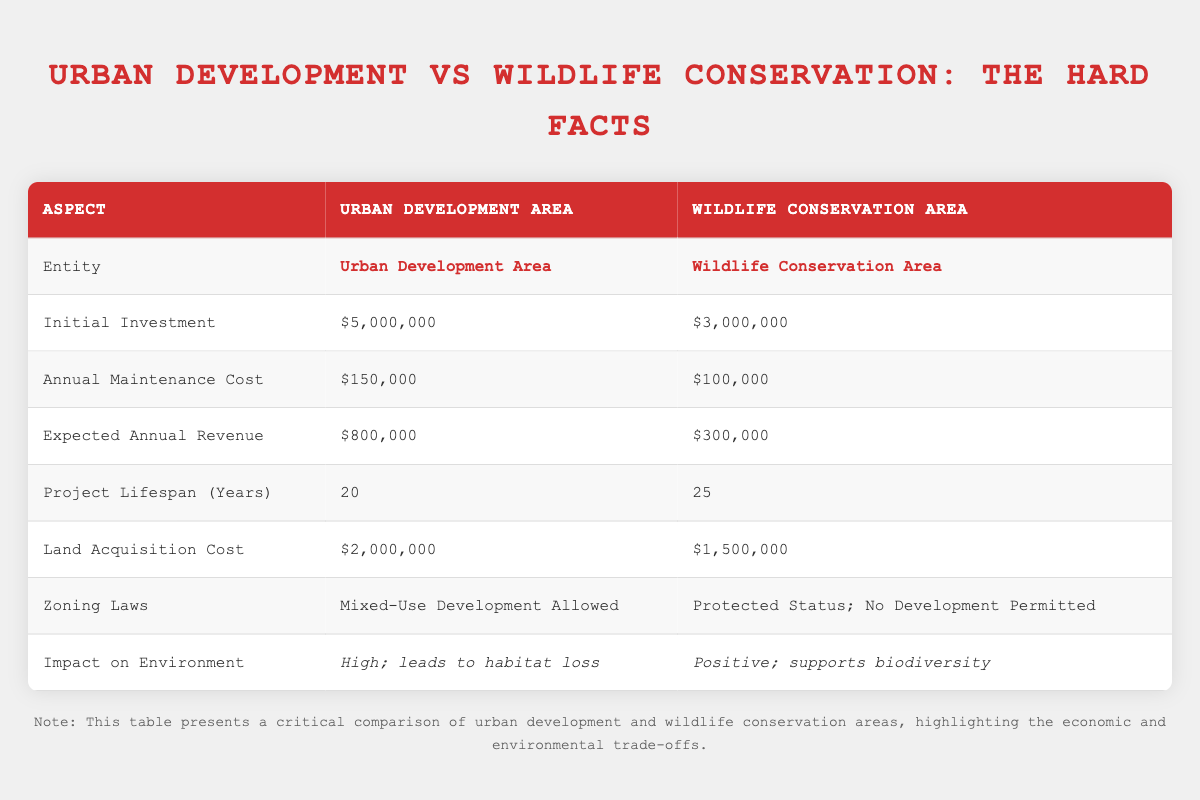What is the initial investment required for the Urban Development Area? The table lists the value under "Initial Investment" for the Urban Development Area, which is $5,000,000.
Answer: $5,000,000 What is the expected annual revenue for the Wildlife Conservation Area? From the table, the expected annual revenue for the Wildlife Conservation Area is directly noted as $300,000.
Answer: $300,000 Which area has a higher annual maintenance cost? Comparing the "Annual Maintenance Cost" for both areas: Urban Development Area has $150,000, while Wildlife Conservation Area has $100,000. Therefore, the Urban Development Area has a higher cost.
Answer: Urban Development Area If we sum the initial investment and land acquisition cost for the Urban Development Area, what total do we get? The initial investment is $5,000,000 and the land acquisition cost is $2,000,000. Adding these amounts gives: $5,000,000 + $2,000,000 = $7,000,000.
Answer: $7,000,000 Is the zoning law for the Wildlife Conservation Area more restrictive than that for the Urban Development Area? The Wildlife Conservation Area has a zoning law of "Protected Status; No Development Permitted," while the Urban Development Area allows "Mixed-Use Development." Thus, the Wildlife Conservation Area has more restrictive zoning laws.
Answer: Yes What is the difference in project lifespan between the urban and wildlife areas? The project lifespan for the Urban Development Area is 20 years, while for the Wildlife Conservation Area it is 25 years. The difference is calculated as: 25 years - 20 years = 5 years.
Answer: 5 years Both areas require maintenance costs annually. How much more does Urban Development cost annually compared to Wildlife Conservation? The Urban Development Area incurs an annual maintenance cost of $150,000, and the Wildlife Conservation Area incurs $100,000. The difference is: $150,000 - $100,000 = $50,000.
Answer: $50,000 Does urban development lead to a positive impact on the environment? The impact on the environment for the Urban Development Area is described as "High; leads to habitat loss," which indicates a negative impact. Therefore, the statement is false.
Answer: No What is the expected total revenue over the lifespan of the Wildlife Conservation Area? The expected annual revenue for the Wildlife Conservation Area is $300,000, and the project lifespan is 25 years. The total is calculated as: $300,000 * 25 years = $7,500,000.
Answer: $7,500,000 